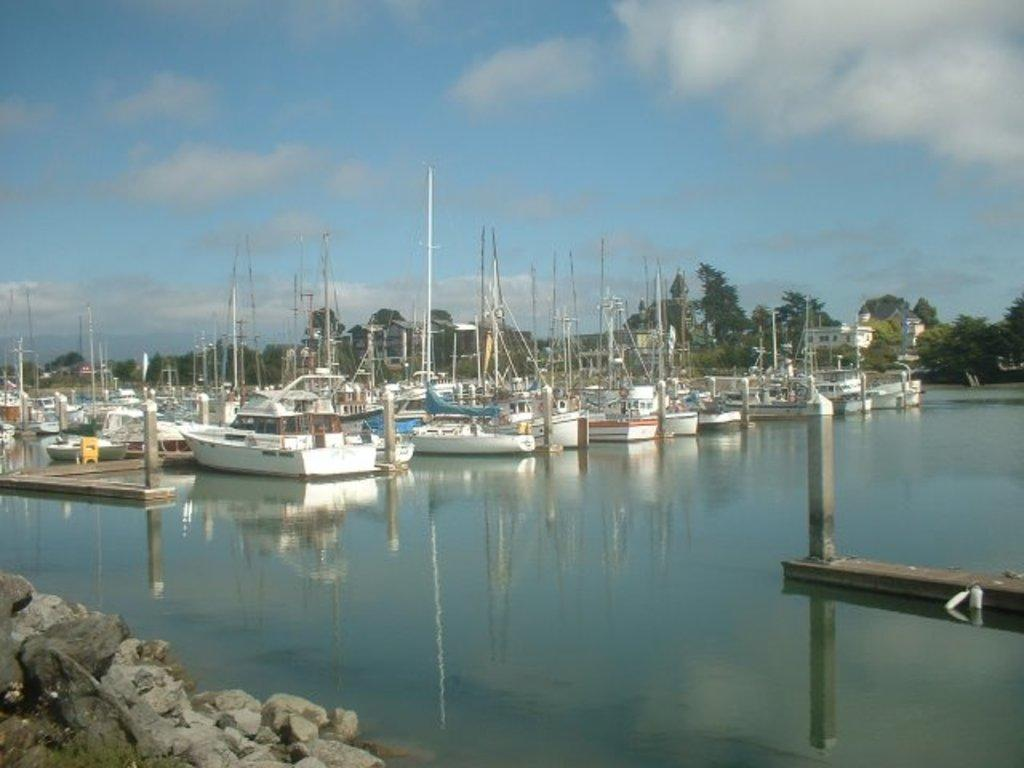What is floating on the water in the image? There are ships floating on the water in the image. What feature can be seen on the ships? The ships have masts. What can be seen in the background of the image? There are many trees visible in the background of the image. What type of playground equipment can be seen in the image? There is no playground equipment present in the image; it features ships floating on the water and trees in the background. 